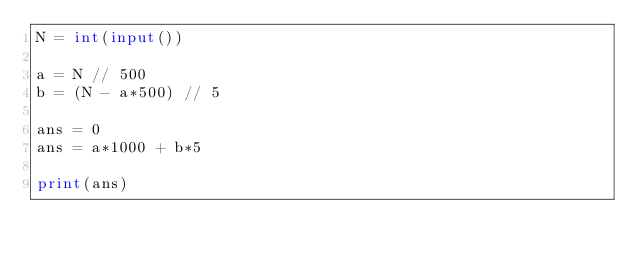<code> <loc_0><loc_0><loc_500><loc_500><_Python_>N = int(input())

a = N // 500
b = (N - a*500) // 5

ans = 0
ans = a*1000 + b*5

print(ans)</code> 